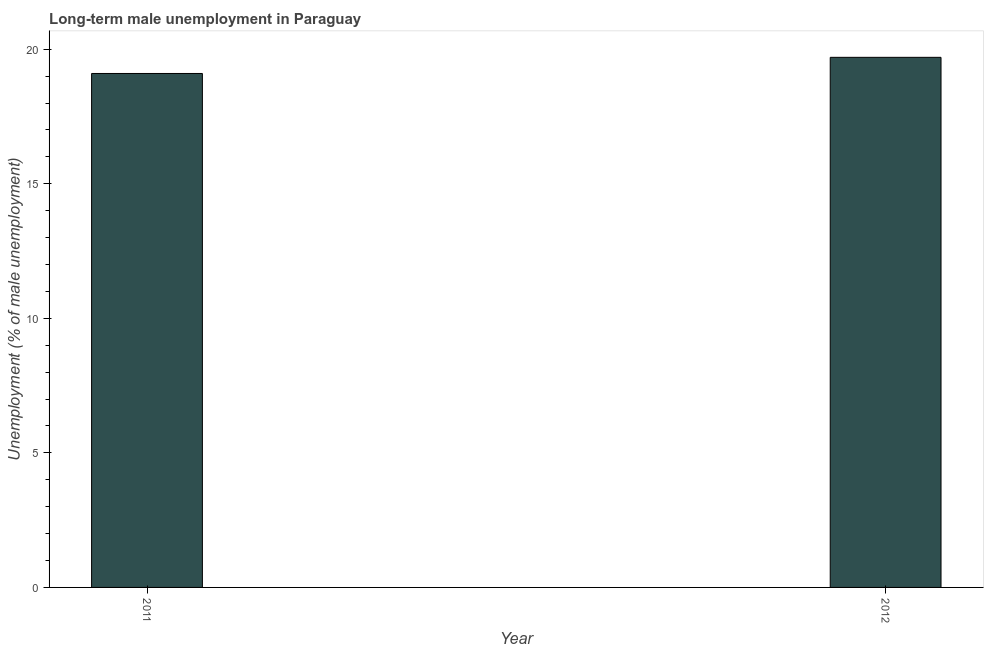Does the graph contain any zero values?
Give a very brief answer. No. Does the graph contain grids?
Offer a terse response. No. What is the title of the graph?
Your response must be concise. Long-term male unemployment in Paraguay. What is the label or title of the Y-axis?
Provide a succinct answer. Unemployment (% of male unemployment). What is the long-term male unemployment in 2012?
Your answer should be very brief. 19.7. Across all years, what is the maximum long-term male unemployment?
Offer a terse response. 19.7. Across all years, what is the minimum long-term male unemployment?
Provide a short and direct response. 19.1. In which year was the long-term male unemployment maximum?
Your answer should be compact. 2012. What is the sum of the long-term male unemployment?
Ensure brevity in your answer.  38.8. What is the difference between the long-term male unemployment in 2011 and 2012?
Your answer should be compact. -0.6. What is the average long-term male unemployment per year?
Your response must be concise. 19.4. What is the median long-term male unemployment?
Provide a short and direct response. 19.4. What is the ratio of the long-term male unemployment in 2011 to that in 2012?
Ensure brevity in your answer.  0.97. Is the long-term male unemployment in 2011 less than that in 2012?
Your response must be concise. Yes. In how many years, is the long-term male unemployment greater than the average long-term male unemployment taken over all years?
Your response must be concise. 1. How many bars are there?
Give a very brief answer. 2. What is the Unemployment (% of male unemployment) of 2011?
Offer a very short reply. 19.1. What is the Unemployment (% of male unemployment) of 2012?
Your answer should be compact. 19.7. 